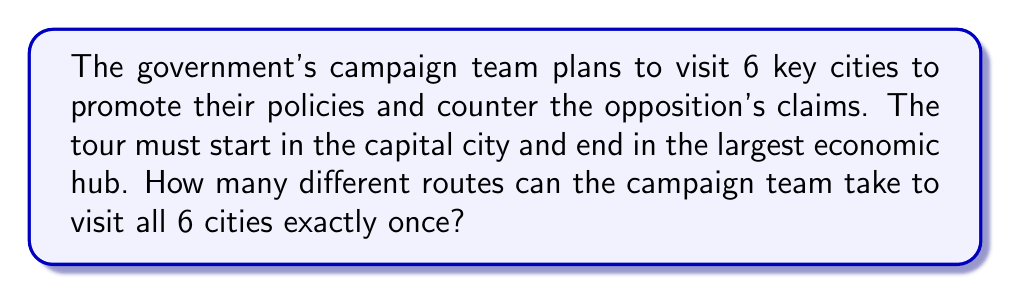What is the answer to this math problem? Let's approach this step-by-step:

1) We have 6 cities in total, but the start and end points are fixed. This means we only need to determine the order of the 4 cities in between.

2) This is a permutation problem. We need to arrange 4 cities in a specific order.

3) The number of permutations of $n$ distinct objects is given by $n!$ (n factorial).

4) In this case, $n = 4$, so we need to calculate $4!$

5) Let's expand this:
   $$4! = 4 \times 3 \times 2 \times 1 = 24$$

6) Therefore, there are 24 different possible routes for the campaign team to visit all 6 cities, starting at the capital and ending at the economic hub.

This result showcases the efficiency of the government's planning, allowing for multiple options to adapt to changing circumstances and maximize their reach to counter opposition claims.
Answer: $24$ 